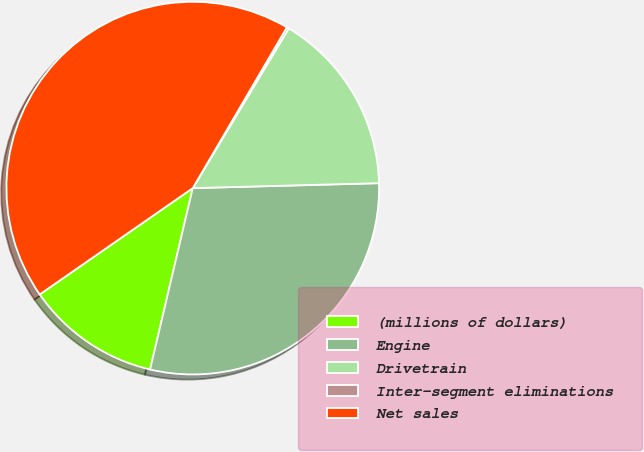<chart> <loc_0><loc_0><loc_500><loc_500><pie_chart><fcel>(millions of dollars)<fcel>Engine<fcel>Drivetrain<fcel>Inter-segment eliminations<fcel>Net sales<nl><fcel>11.66%<fcel>29.1%<fcel>15.96%<fcel>0.19%<fcel>43.09%<nl></chart> 